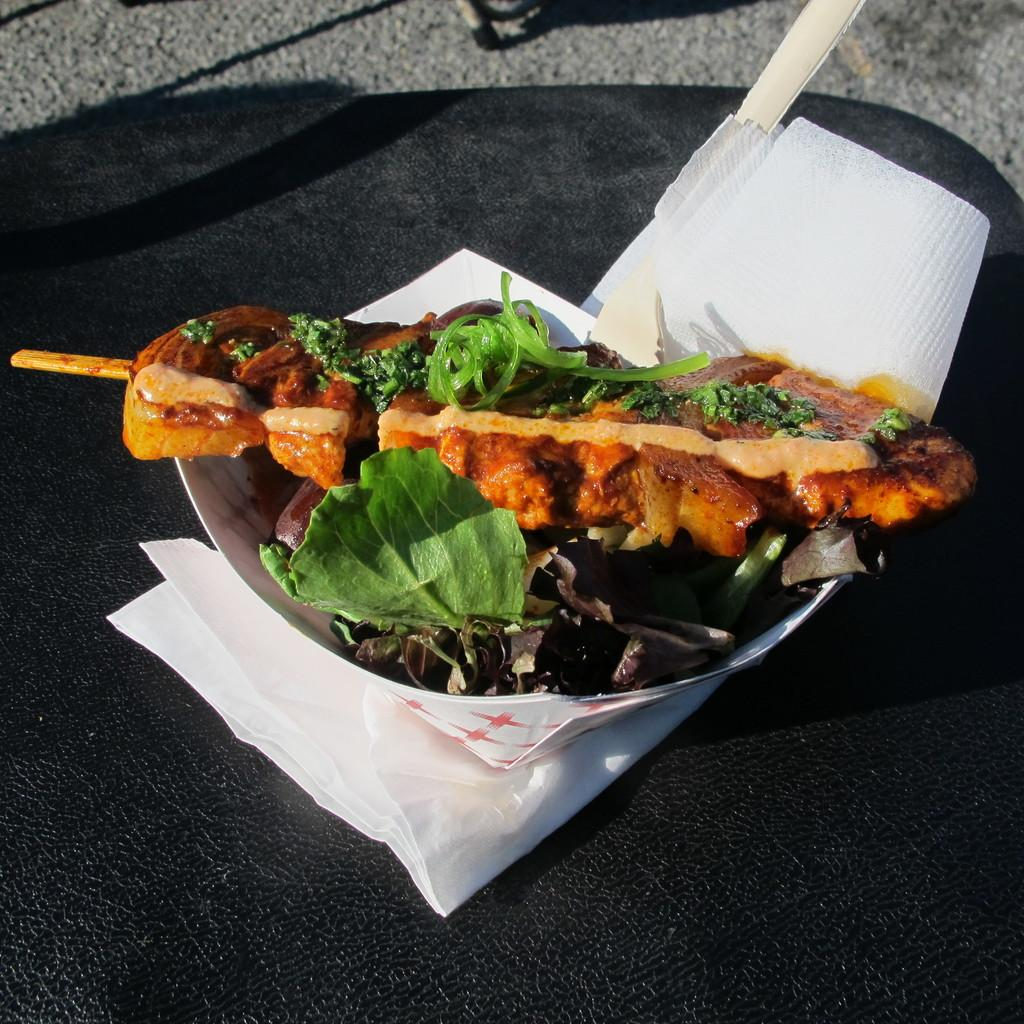What is on the plate in the image? There is food on the plate in the image. What can be found on the table in addition to the plate? Tissue papers are present on the table in the image. What type of lip can be seen on the plate in the image? There is no lip present on the plate in the image; it contains food. 